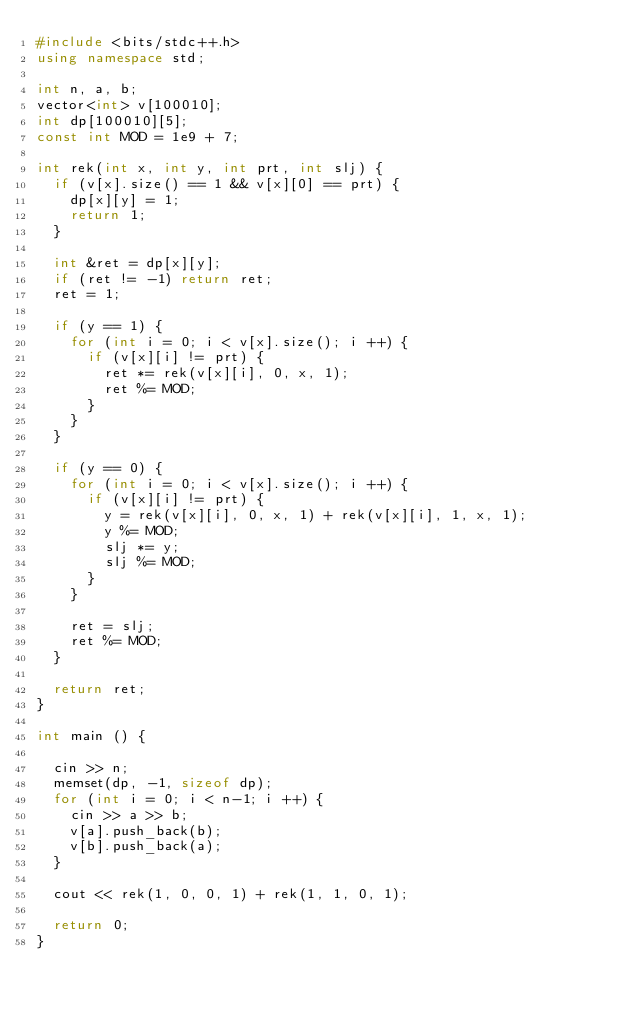Convert code to text. <code><loc_0><loc_0><loc_500><loc_500><_C++_>#include <bits/stdc++.h>
using namespace std;

int n, a, b;
vector<int> v[100010];
int dp[100010][5];
const int MOD = 1e9 + 7;

int rek(int x, int y, int prt, int slj) {
	if (v[x].size() == 1 && v[x][0] == prt) {
		dp[x][y] = 1;
		return 1;
	}
	
	int &ret = dp[x][y];
	if (ret != -1) return ret;
	ret = 1;
	
	if (y == 1) {
		for (int i = 0; i < v[x].size(); i ++) {
			if (v[x][i] != prt) {
				ret *= rek(v[x][i], 0, x, 1);
				ret %= MOD;
			}
		}
	}
	
	if (y == 0) {
		for (int i = 0; i < v[x].size(); i ++) {
			if (v[x][i] != prt) {
				y = rek(v[x][i], 0, x, 1) + rek(v[x][i], 1, x, 1);
				y %= MOD;
				slj *= y;
				slj %= MOD;
			}
		}
		
		ret = slj;
		ret %= MOD;
	}
	
	return ret;
}

int main () {
	
	cin >> n;
	memset(dp, -1, sizeof dp);
	for (int i = 0; i < n-1; i ++) {
		cin >> a >> b;
		v[a].push_back(b);
		v[b].push_back(a);
	}
	
	cout << rek(1, 0, 0, 1) + rek(1, 1, 0, 1);
	
	return 0;
}</code> 